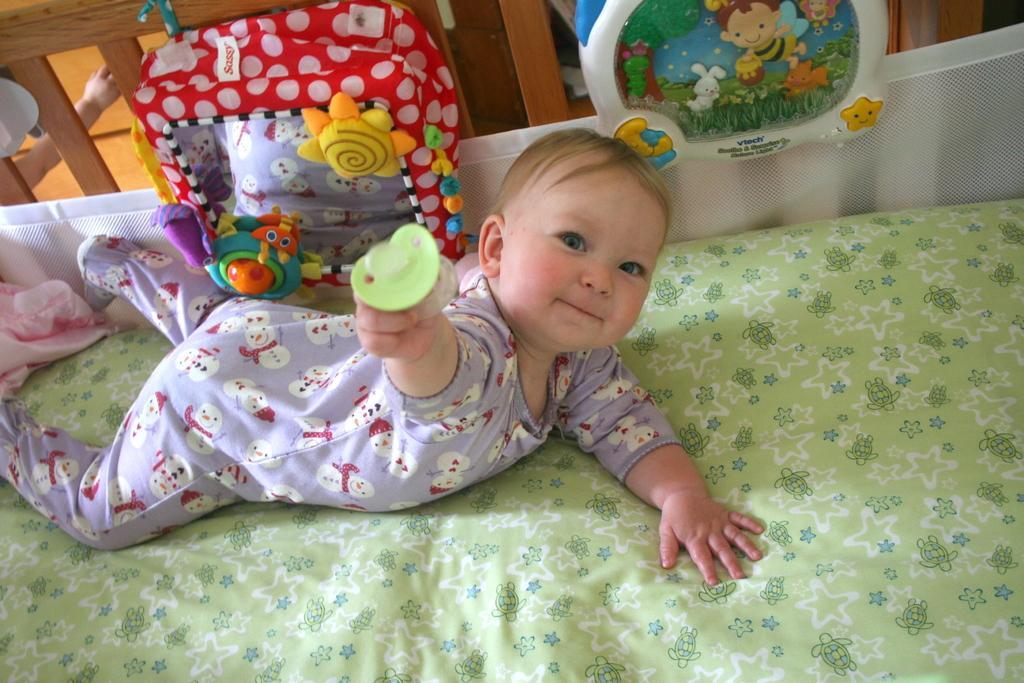Describe this image in one or two sentences. In this picture I can observe a baby lying on the bed. In the background I can observe toys. 